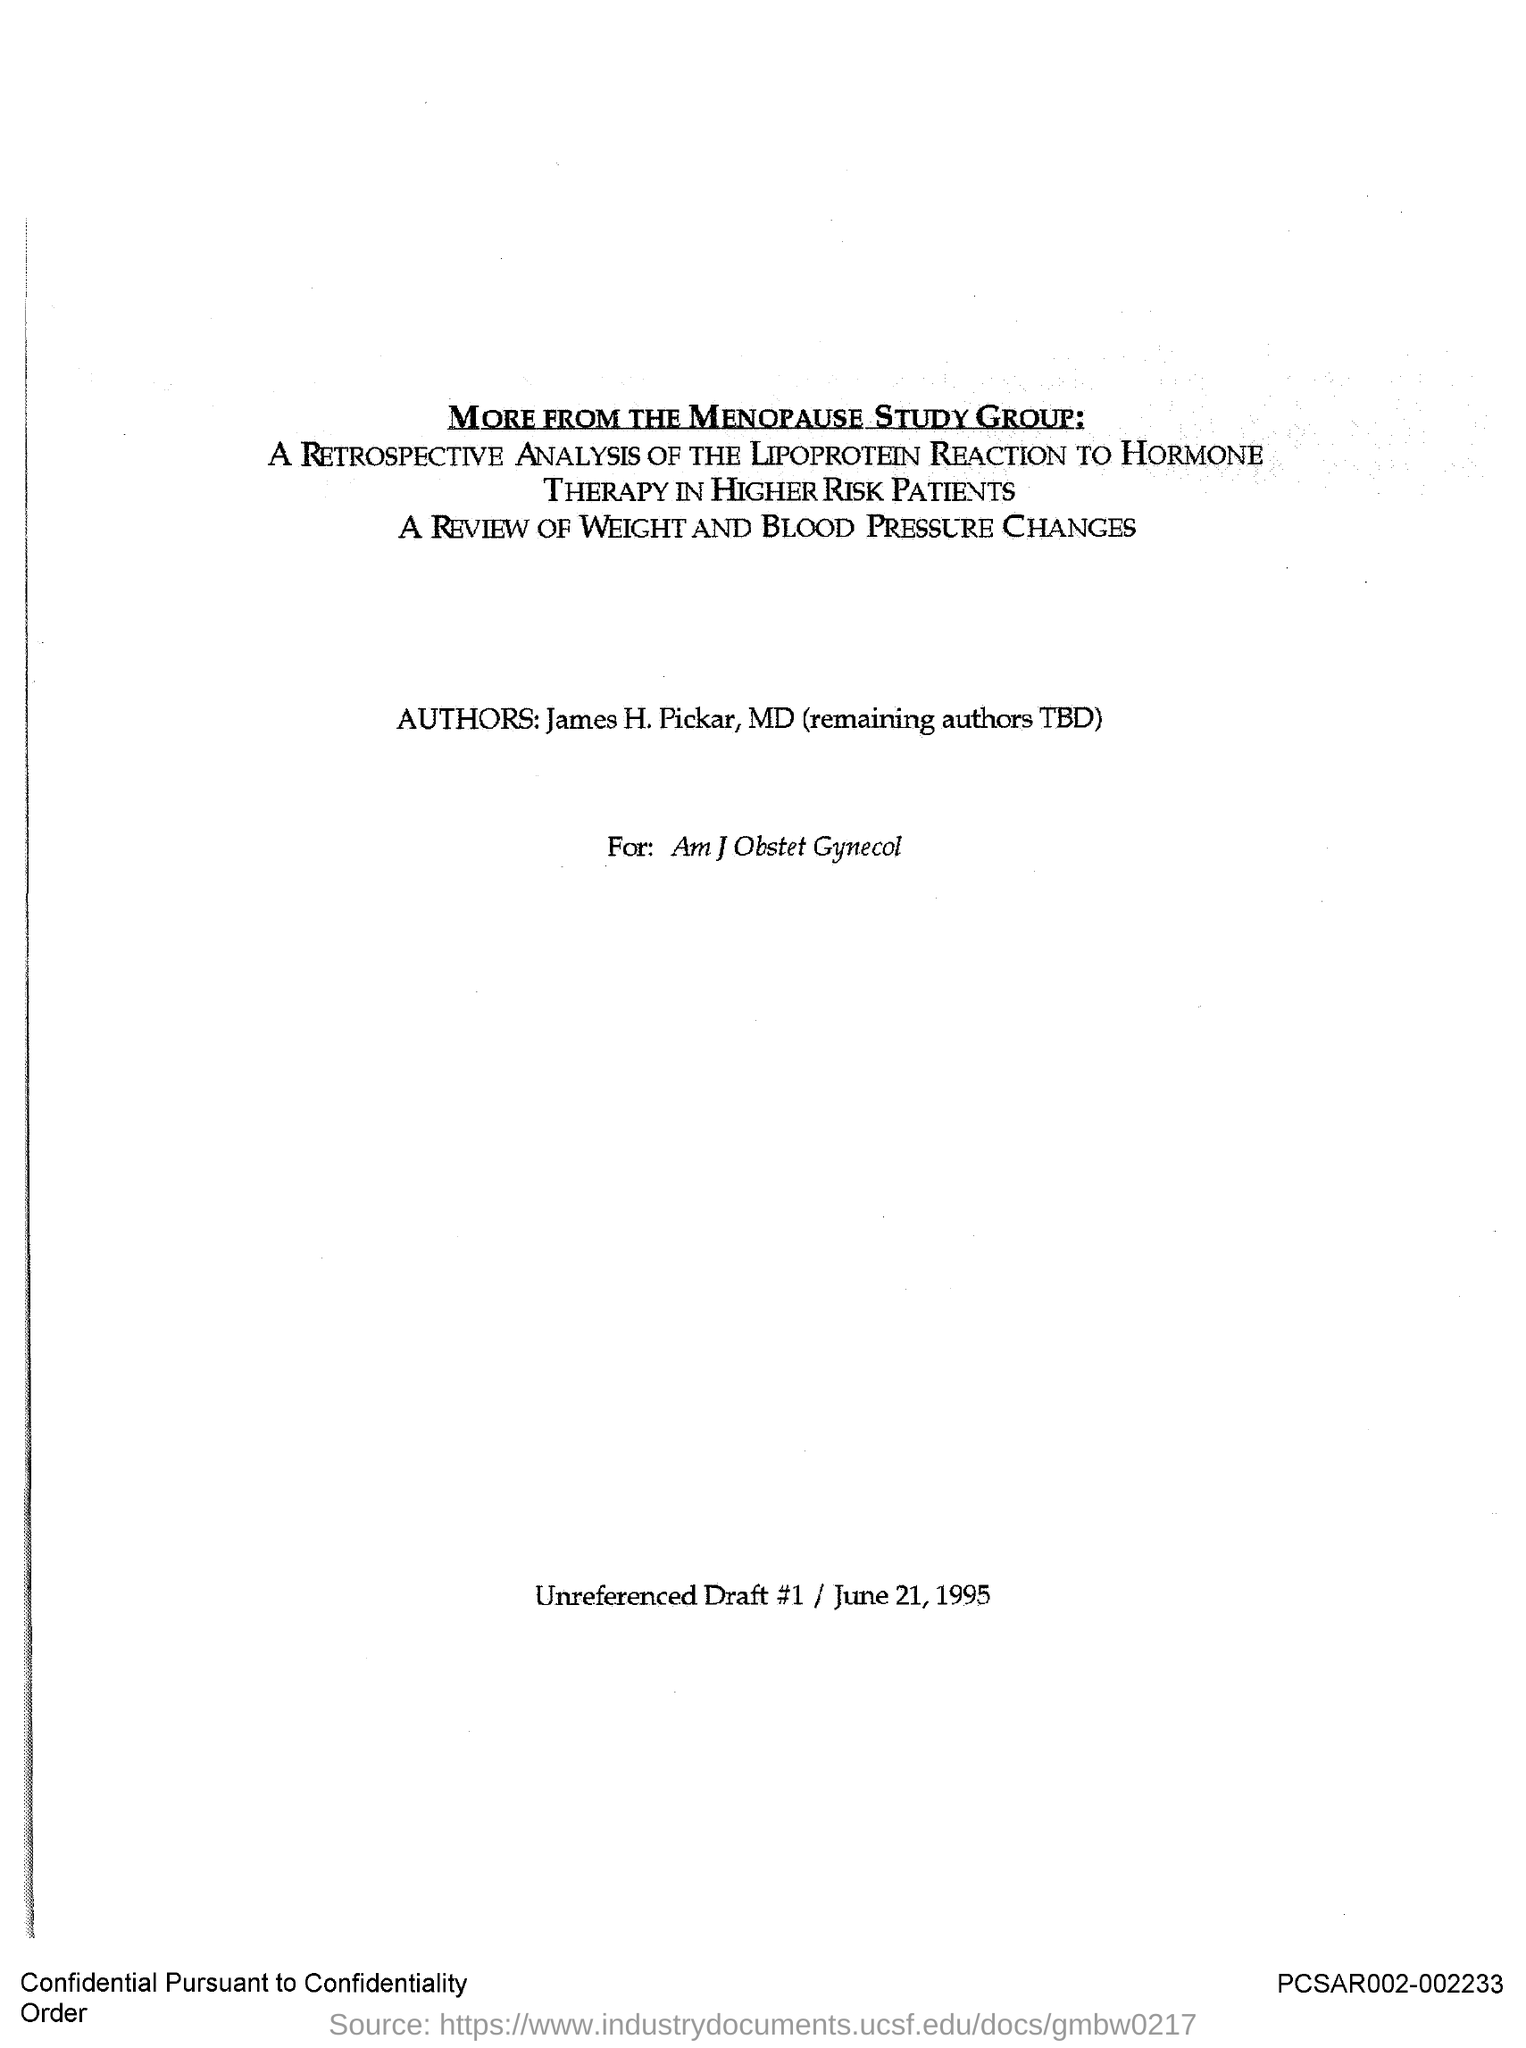Who are the authors mentioned?
Keep it short and to the point. James H. Pickar, MD (remaining authors TBD). What category of patients is studied?
Your answer should be very brief. Higher risk patients. Which study group name is mentioned  at the top?
Your answer should be compact. The menopause study group. What is the date in the document?
Keep it short and to the point. June 21, 1995. 